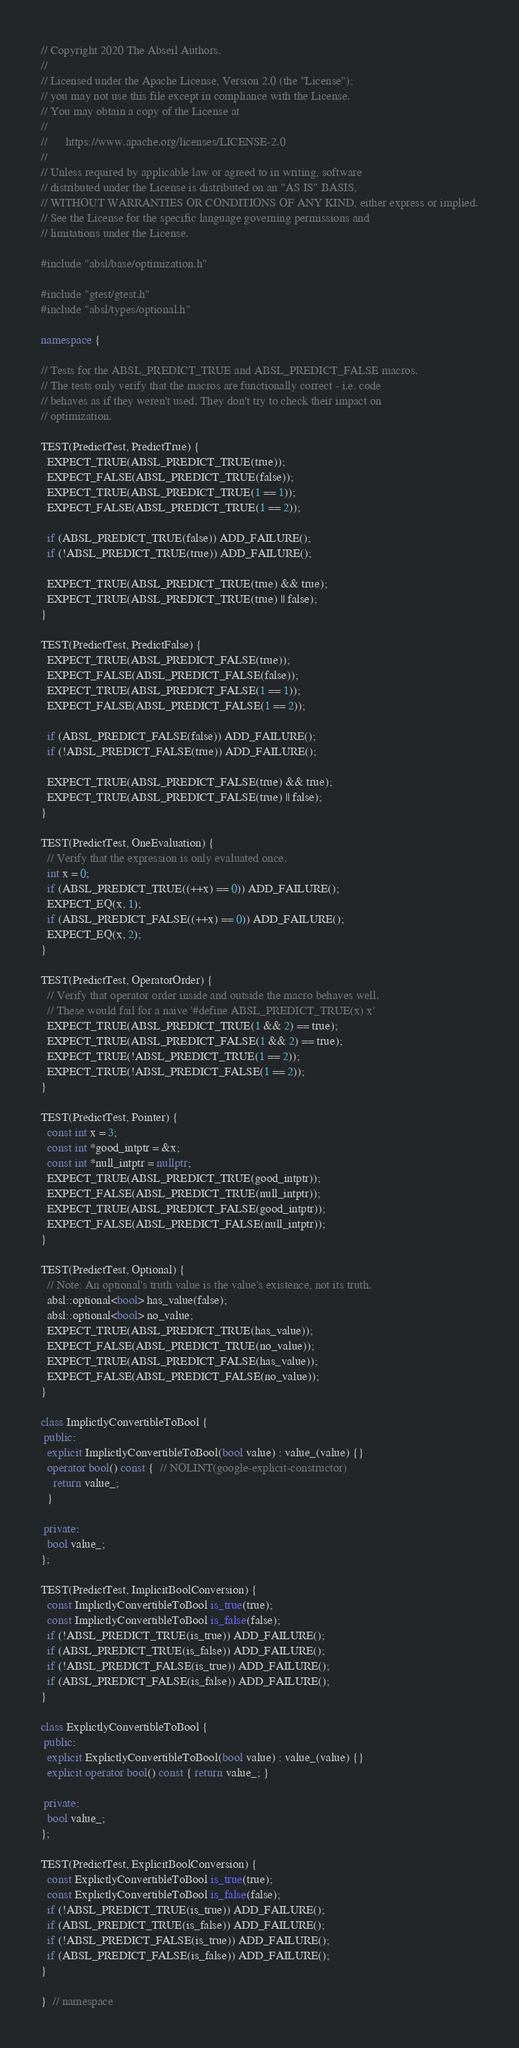Convert code to text. <code><loc_0><loc_0><loc_500><loc_500><_C++_>// Copyright 2020 The Abseil Authors.
//
// Licensed under the Apache License, Version 2.0 (the "License");
// you may not use this file except in compliance with the License.
// You may obtain a copy of the License at
//
//      https://www.apache.org/licenses/LICENSE-2.0
//
// Unless required by applicable law or agreed to in writing, software
// distributed under the License is distributed on an "AS IS" BASIS,
// WITHOUT WARRANTIES OR CONDITIONS OF ANY KIND, either express or implied.
// See the License for the specific language governing permissions and
// limitations under the License.

#include "absl/base/optimization.h"

#include "gtest/gtest.h"
#include "absl/types/optional.h"

namespace {

// Tests for the ABSL_PREDICT_TRUE and ABSL_PREDICT_FALSE macros.
// The tests only verify that the macros are functionally correct - i.e. code
// behaves as if they weren't used. They don't try to check their impact on
// optimization.

TEST(PredictTest, PredictTrue) {
  EXPECT_TRUE(ABSL_PREDICT_TRUE(true));
  EXPECT_FALSE(ABSL_PREDICT_TRUE(false));
  EXPECT_TRUE(ABSL_PREDICT_TRUE(1 == 1));
  EXPECT_FALSE(ABSL_PREDICT_TRUE(1 == 2));

  if (ABSL_PREDICT_TRUE(false)) ADD_FAILURE();
  if (!ABSL_PREDICT_TRUE(true)) ADD_FAILURE();

  EXPECT_TRUE(ABSL_PREDICT_TRUE(true) && true);
  EXPECT_TRUE(ABSL_PREDICT_TRUE(true) || false);
}

TEST(PredictTest, PredictFalse) {
  EXPECT_TRUE(ABSL_PREDICT_FALSE(true));
  EXPECT_FALSE(ABSL_PREDICT_FALSE(false));
  EXPECT_TRUE(ABSL_PREDICT_FALSE(1 == 1));
  EXPECT_FALSE(ABSL_PREDICT_FALSE(1 == 2));

  if (ABSL_PREDICT_FALSE(false)) ADD_FAILURE();
  if (!ABSL_PREDICT_FALSE(true)) ADD_FAILURE();

  EXPECT_TRUE(ABSL_PREDICT_FALSE(true) && true);
  EXPECT_TRUE(ABSL_PREDICT_FALSE(true) || false);
}

TEST(PredictTest, OneEvaluation) {
  // Verify that the expression is only evaluated once.
  int x = 0;
  if (ABSL_PREDICT_TRUE((++x) == 0)) ADD_FAILURE();
  EXPECT_EQ(x, 1);
  if (ABSL_PREDICT_FALSE((++x) == 0)) ADD_FAILURE();
  EXPECT_EQ(x, 2);
}

TEST(PredictTest, OperatorOrder) {
  // Verify that operator order inside and outside the macro behaves well.
  // These would fail for a naive '#define ABSL_PREDICT_TRUE(x) x'
  EXPECT_TRUE(ABSL_PREDICT_TRUE(1 && 2) == true);
  EXPECT_TRUE(ABSL_PREDICT_FALSE(1 && 2) == true);
  EXPECT_TRUE(!ABSL_PREDICT_TRUE(1 == 2));
  EXPECT_TRUE(!ABSL_PREDICT_FALSE(1 == 2));
}

TEST(PredictTest, Pointer) {
  const int x = 3;
  const int *good_intptr = &x;
  const int *null_intptr = nullptr;
  EXPECT_TRUE(ABSL_PREDICT_TRUE(good_intptr));
  EXPECT_FALSE(ABSL_PREDICT_TRUE(null_intptr));
  EXPECT_TRUE(ABSL_PREDICT_FALSE(good_intptr));
  EXPECT_FALSE(ABSL_PREDICT_FALSE(null_intptr));
}

TEST(PredictTest, Optional) {
  // Note: An optional's truth value is the value's existence, not its truth.
  absl::optional<bool> has_value(false);
  absl::optional<bool> no_value;
  EXPECT_TRUE(ABSL_PREDICT_TRUE(has_value));
  EXPECT_FALSE(ABSL_PREDICT_TRUE(no_value));
  EXPECT_TRUE(ABSL_PREDICT_FALSE(has_value));
  EXPECT_FALSE(ABSL_PREDICT_FALSE(no_value));
}

class ImplictlyConvertibleToBool {
 public:
  explicit ImplictlyConvertibleToBool(bool value) : value_(value) {}
  operator bool() const {  // NOLINT(google-explicit-constructor)
    return value_;
  }

 private:
  bool value_;
};

TEST(PredictTest, ImplicitBoolConversion) {
  const ImplictlyConvertibleToBool is_true(true);
  const ImplictlyConvertibleToBool is_false(false);
  if (!ABSL_PREDICT_TRUE(is_true)) ADD_FAILURE();
  if (ABSL_PREDICT_TRUE(is_false)) ADD_FAILURE();
  if (!ABSL_PREDICT_FALSE(is_true)) ADD_FAILURE();
  if (ABSL_PREDICT_FALSE(is_false)) ADD_FAILURE();
}

class ExplictlyConvertibleToBool {
 public:
  explicit ExplictlyConvertibleToBool(bool value) : value_(value) {}
  explicit operator bool() const { return value_; }

 private:
  bool value_;
};

TEST(PredictTest, ExplicitBoolConversion) {
  const ExplictlyConvertibleToBool is_true(true);
  const ExplictlyConvertibleToBool is_false(false);
  if (!ABSL_PREDICT_TRUE(is_true)) ADD_FAILURE();
  if (ABSL_PREDICT_TRUE(is_false)) ADD_FAILURE();
  if (!ABSL_PREDICT_FALSE(is_true)) ADD_FAILURE();
  if (ABSL_PREDICT_FALSE(is_false)) ADD_FAILURE();
}

}  // namespace
</code> 